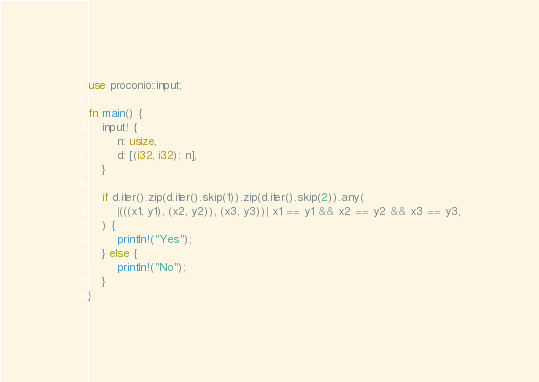<code> <loc_0><loc_0><loc_500><loc_500><_Rust_>use proconio::input;

fn main() {
    input! {
        n: usize,
        d: [(i32, i32); n],
    }

    if d.iter().zip(d.iter().skip(1)).zip(d.iter().skip(2)).any(
        |(((x1, y1), (x2, y2)), (x3, y3))| x1 == y1 && x2 == y2 && x3 == y3,
    ) {
        println!("Yes");
    } else {
        println!("No");
    }
}
</code> 